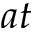Convert formula to latex. <formula><loc_0><loc_0><loc_500><loc_500>a t</formula> 